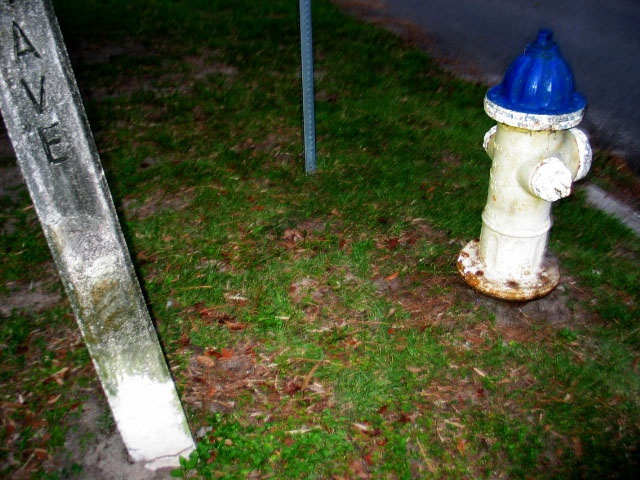Describe the objects in this image and their specific colors. I can see a fire hydrant in purple, ivory, darkblue, beige, and navy tones in this image. 